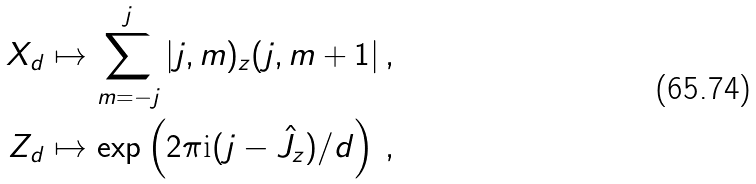Convert formula to latex. <formula><loc_0><loc_0><loc_500><loc_500>X _ { d } & \mapsto \sum _ { m = - j } ^ { j } | j , m ) _ { z } ( j , m + 1 | \, , \\ Z _ { d } & \mapsto \exp \left ( 2 \pi \text {i} ( j - \hat { J } _ { z } ) / d \right ) \, ,</formula> 